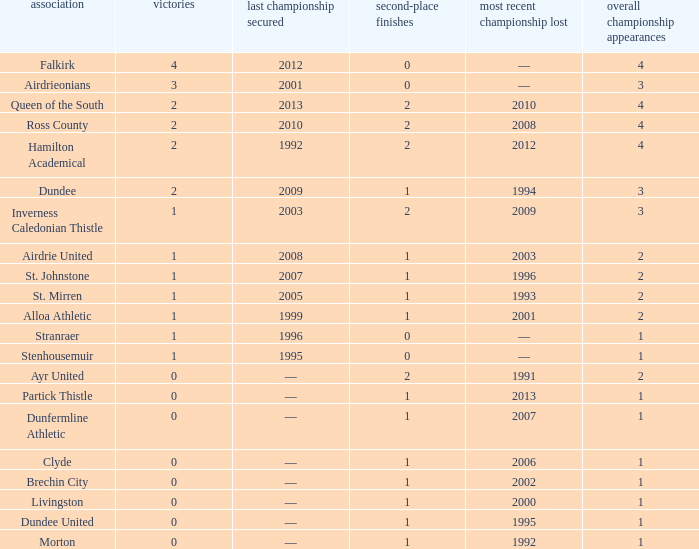How manywins for dunfermline athletic that has a total final appearances less than 2? 0.0. 